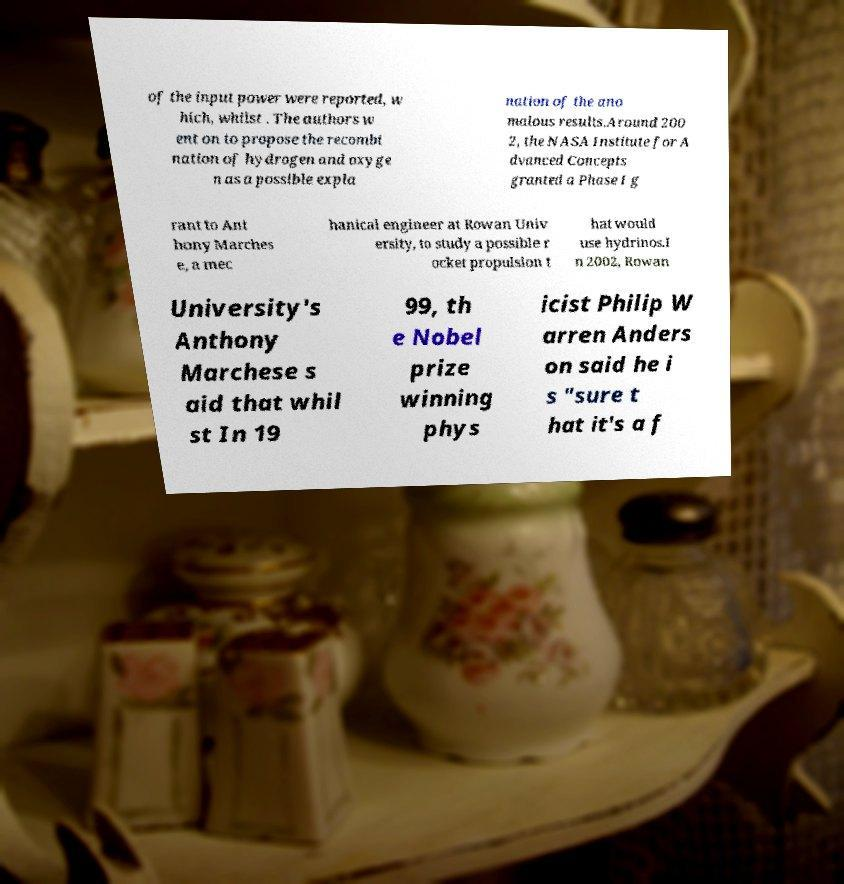I need the written content from this picture converted into text. Can you do that? of the input power were reported, w hich, whilst . The authors w ent on to propose the recombi nation of hydrogen and oxyge n as a possible expla nation of the ano malous results.Around 200 2, the NASA Institute for A dvanced Concepts granted a Phase I g rant to Ant hony Marches e, a mec hanical engineer at Rowan Univ ersity, to study a possible r ocket propulsion t hat would use hydrinos.I n 2002, Rowan University's Anthony Marchese s aid that whil st In 19 99, th e Nobel prize winning phys icist Philip W arren Anders on said he i s "sure t hat it's a f 